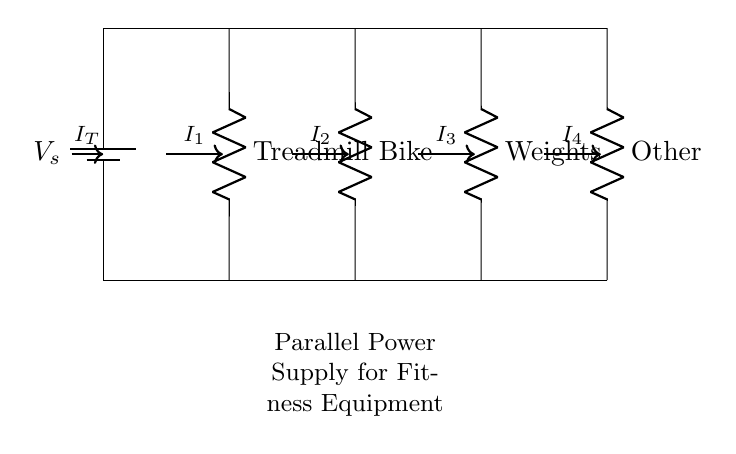What is the type of circuit depicted here? This circuit is a parallel circuit because it has multiple branches (Treadmill, Bike, Weights, Other) where each component is connected directly to the voltage source.
Answer: Parallel What are the components connected in this circuit? The components are Treadmill, Bike, Weights, and Other, which are all resistors connected in parallel.
Answer: Treadmill, Bike, Weights, Other How many current paths are there? There are four separate current paths represented by the four branches leading from the main circuit to each device.
Answer: Four What is the total current entering the circuit? The total current entering the circuit is represented as IT, which is the sum of all individual currents flowing through each branch.
Answer: IT What happens to the voltage across each component in this circuit? The voltage across each component remains the same and is equal to the supply voltage (Vs) because in parallel circuits, voltage remains constant across each branch.
Answer: Same as Vs Which component would receive less current if all devices were active? Each component will receive a different amount of current depending on its resistance; the component with the highest resistance will receive less current.
Answer: Highest resistance component 